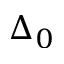Convert formula to latex. <formula><loc_0><loc_0><loc_500><loc_500>\Delta _ { 0 }</formula> 